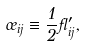Convert formula to latex. <formula><loc_0><loc_0><loc_500><loc_500>\sigma _ { i j } \equiv \frac { 1 } { 2 } \gamma _ { i j } ^ { \prime } ,</formula> 